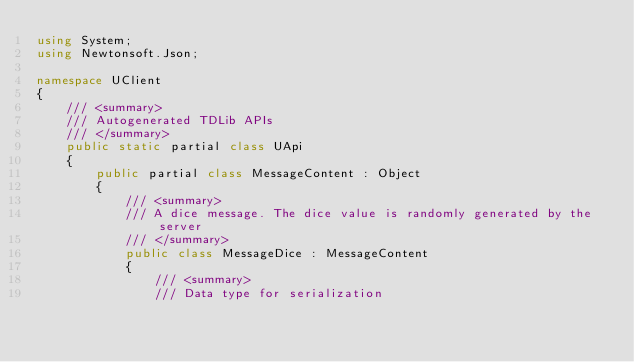Convert code to text. <code><loc_0><loc_0><loc_500><loc_500><_C#_>using System;
using Newtonsoft.Json;

namespace UClient
{
    /// <summary>
    /// Autogenerated TDLib APIs
    /// </summary>
    public static partial class UApi
    {
        public partial class MessageContent : Object
        {
            /// <summary>
            /// A dice message. The dice value is randomly generated by the server
            /// </summary>
            public class MessageDice : MessageContent
            {
                /// <summary>
                /// Data type for serialization</code> 